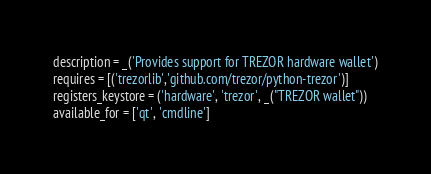<code> <loc_0><loc_0><loc_500><loc_500><_Python_>description = _('Provides support for TREZOR hardware wallet')
requires = [('trezorlib','github.com/trezor/python-trezor')]
registers_keystore = ('hardware', 'trezor', _("TREZOR wallet"))
available_for = ['qt', 'cmdline']

</code> 